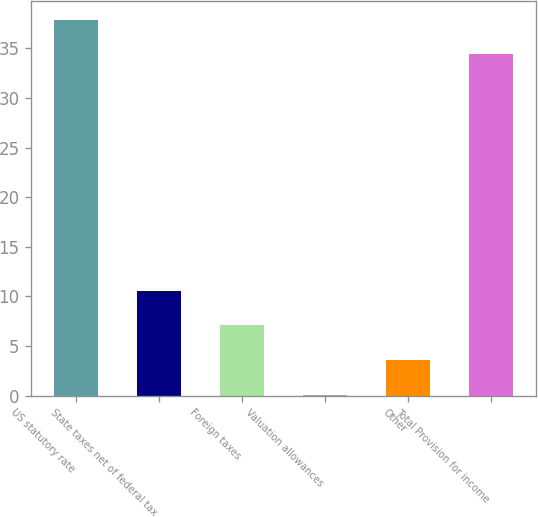<chart> <loc_0><loc_0><loc_500><loc_500><bar_chart><fcel>US statutory rate<fcel>State taxes net of federal tax<fcel>Foreign taxes<fcel>Valuation allowances<fcel>Other<fcel>Total Provision for income<nl><fcel>37.89<fcel>10.57<fcel>7.08<fcel>0.1<fcel>3.59<fcel>34.4<nl></chart> 